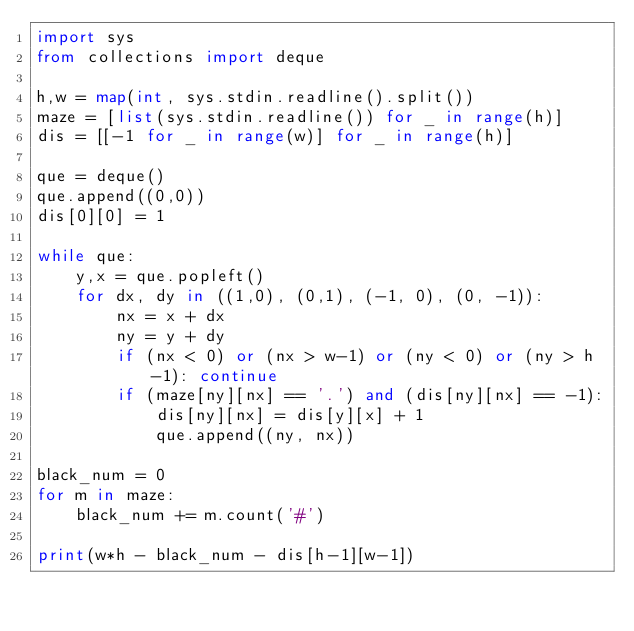<code> <loc_0><loc_0><loc_500><loc_500><_Python_>import sys
from collections import deque

h,w = map(int, sys.stdin.readline().split())
maze = [list(sys.stdin.readline()) for _ in range(h)]
dis = [[-1 for _ in range(w)] for _ in range(h)]

que = deque()
que.append((0,0))
dis[0][0] = 1

while que:
    y,x = que.popleft()
    for dx, dy in ((1,0), (0,1), (-1, 0), (0, -1)):
        nx = x + dx
        ny = y + dy
        if (nx < 0) or (nx > w-1) or (ny < 0) or (ny > h-1): continue
        if (maze[ny][nx] == '.') and (dis[ny][nx] == -1):
            dis[ny][nx] = dis[y][x] + 1
            que.append((ny, nx))

black_num = 0
for m in maze:
    black_num += m.count('#')

print(w*h - black_num - dis[h-1][w-1])
</code> 